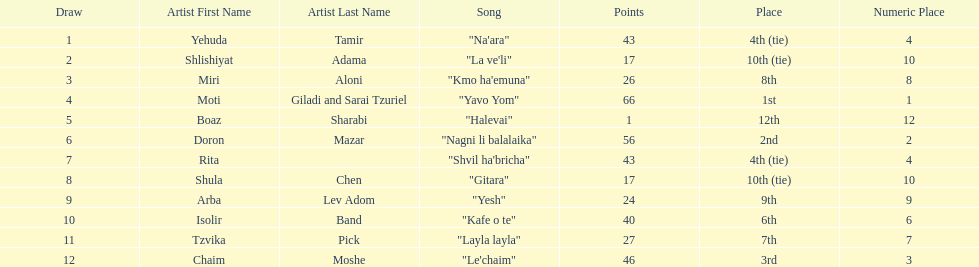Did the song "gitara" or "yesh" earn more points? "Yesh". 